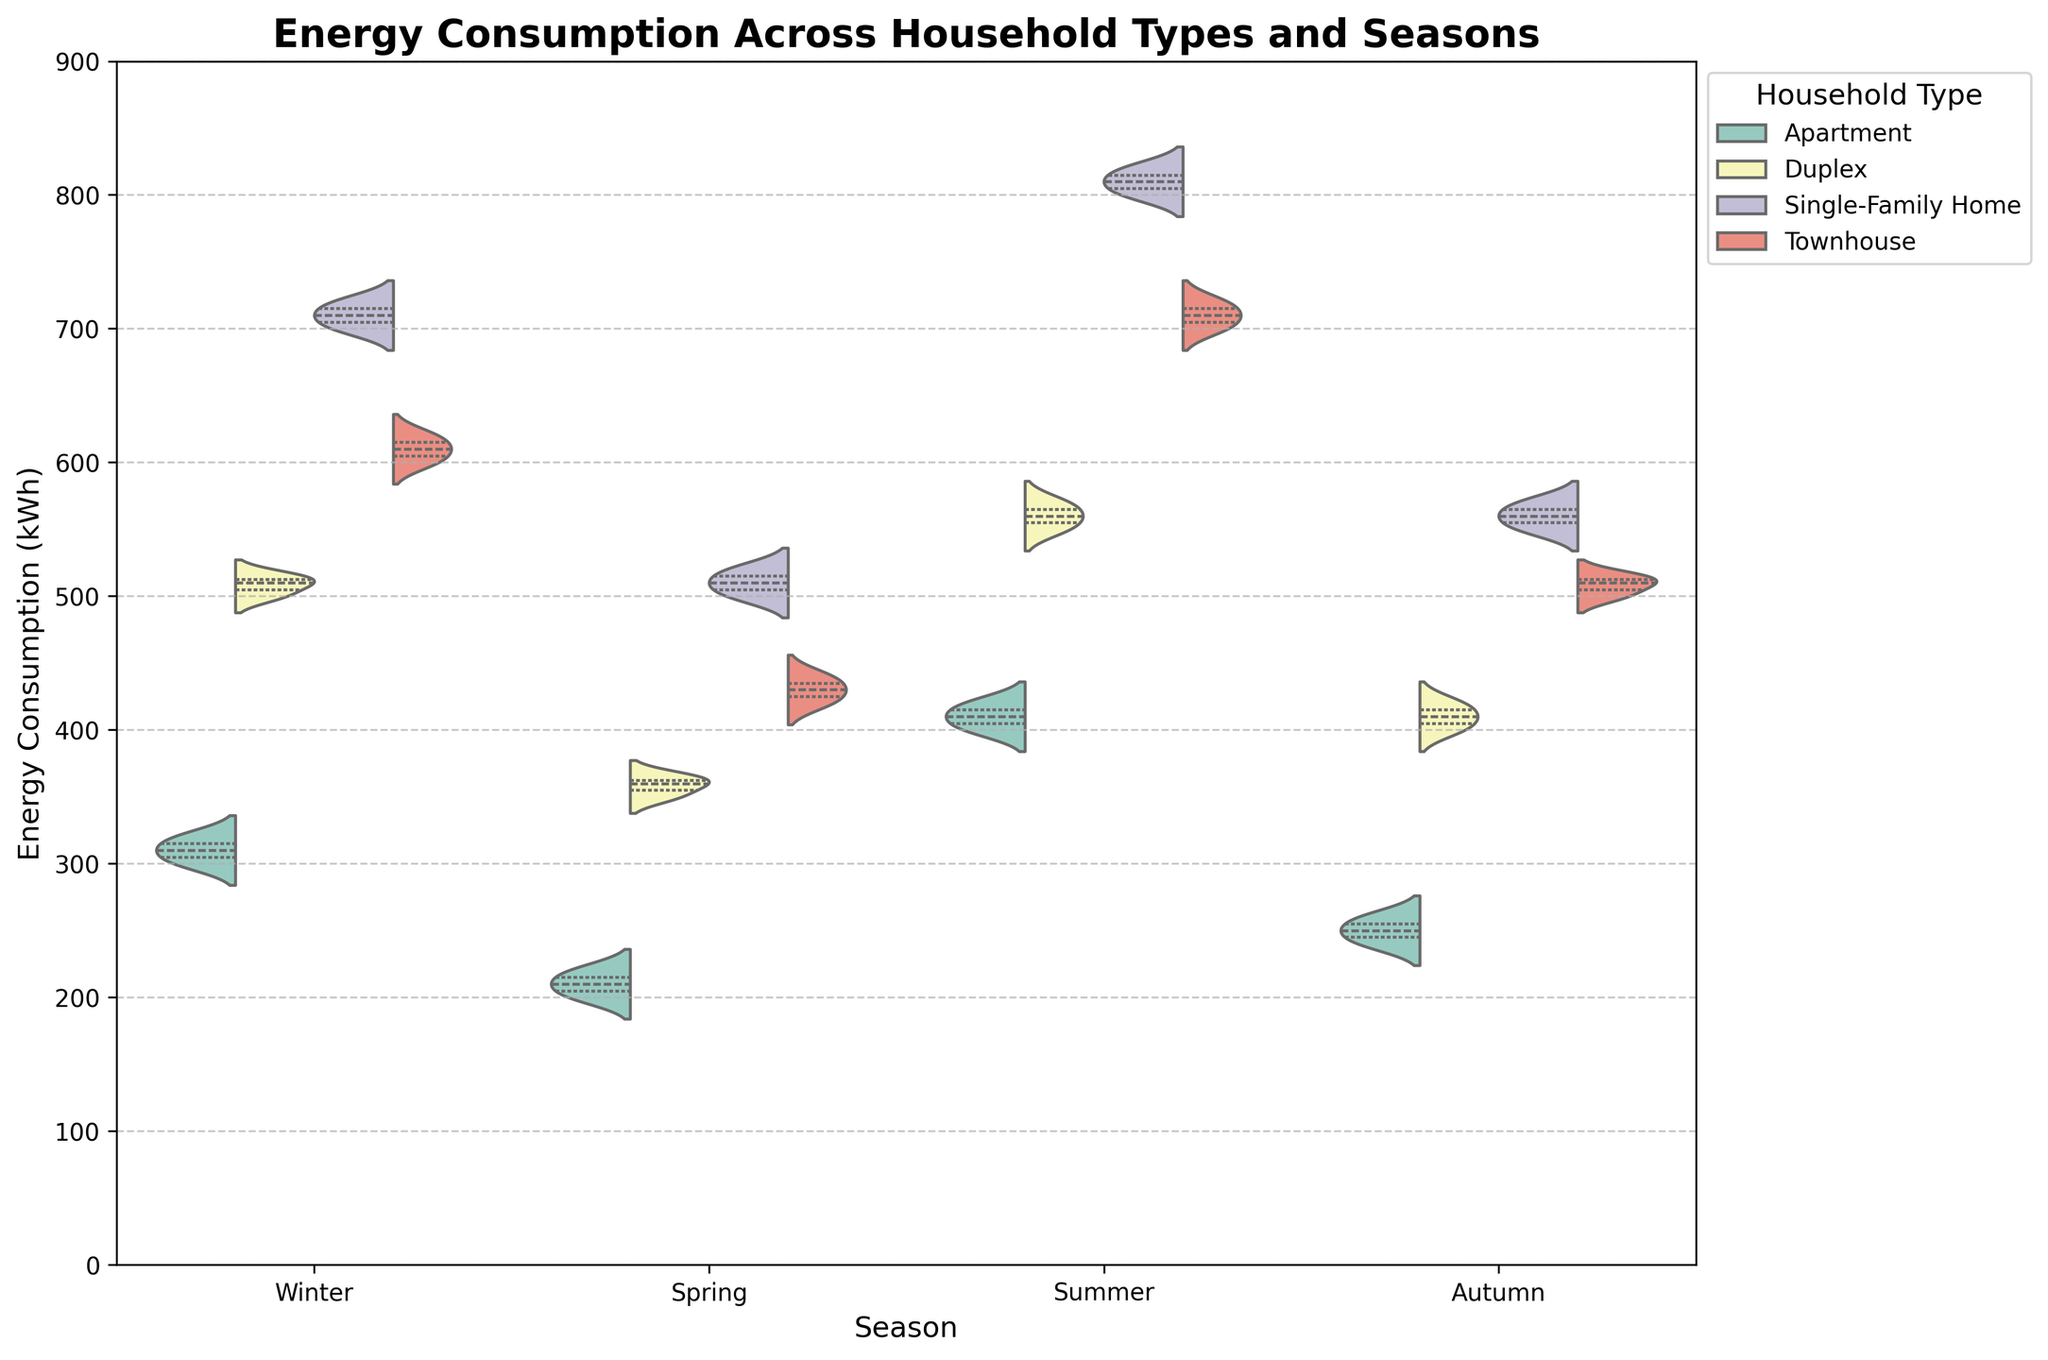What is the title of the graph? Look at the top of the plot where the title is typically located.
Answer: Energy Consumption Across Household Types and Seasons In which season does the Single-Family Home have the highest energy consumption? Observe the Single-Family Home data distributions across different seasons. The highest values are seen in one specific season.
Answer: Summer Which season shows the lowest energy consumption for Apartments? Examine the energy consumption distribution for Apartments across all seasons and identify the one with the lowest values.
Answer: Spring What is the median energy consumption for Townhouses in Winter? The violin plot's inner quartile lines represent the median values. Identify the median line for Townhouses in Winter.
Answer: 610 kWh How does the energy consumption in Summer differ between Duplexes and Single-Family Homes? Compare the width, height, and position of the violin plot sections for Duplexes and Single-Family Homes in Summer. Duplexes generally have a range of 550-570 kWh, while Single-Family Homes range between 800-820 kWh. Calculate the difference between these ranges.
Answer: 250 kWh Which household type shows the most variation in energy consumption in Autumn? Analyze the spread (width and height) of the violin plots for each household type in Autumn. The one with the widest spread indicates the most variation.
Answer: Single-Family Home What is the average increase in energy consumption from Spring to Summer for Townhouses? Determine the average energy consumption in Spring and Summer for Townhouses. Average Spring: (420+430+440)/3 = 430 kWh; Average Summer: (700+710+720)/3 = 710 kWh. The difference is 710 - 430.
Answer: 280 kWh Among the different household types, which one has the widest energy consumption range in Winter? Compare the range of the violins (top of the highest point to the bottom of the lowest point) for each household type in Winter.
Answer: Single-Family Home How does the energy consumption in Spring compare across all household types? Look at the position and spread of the violins for all household types in Spring. Townhouses show the lowest, followed by Apartments, Duplexes, and Single-Family Homes.
Answer: Townhouses < Apartments < Duplexes < Single-Family Homes 